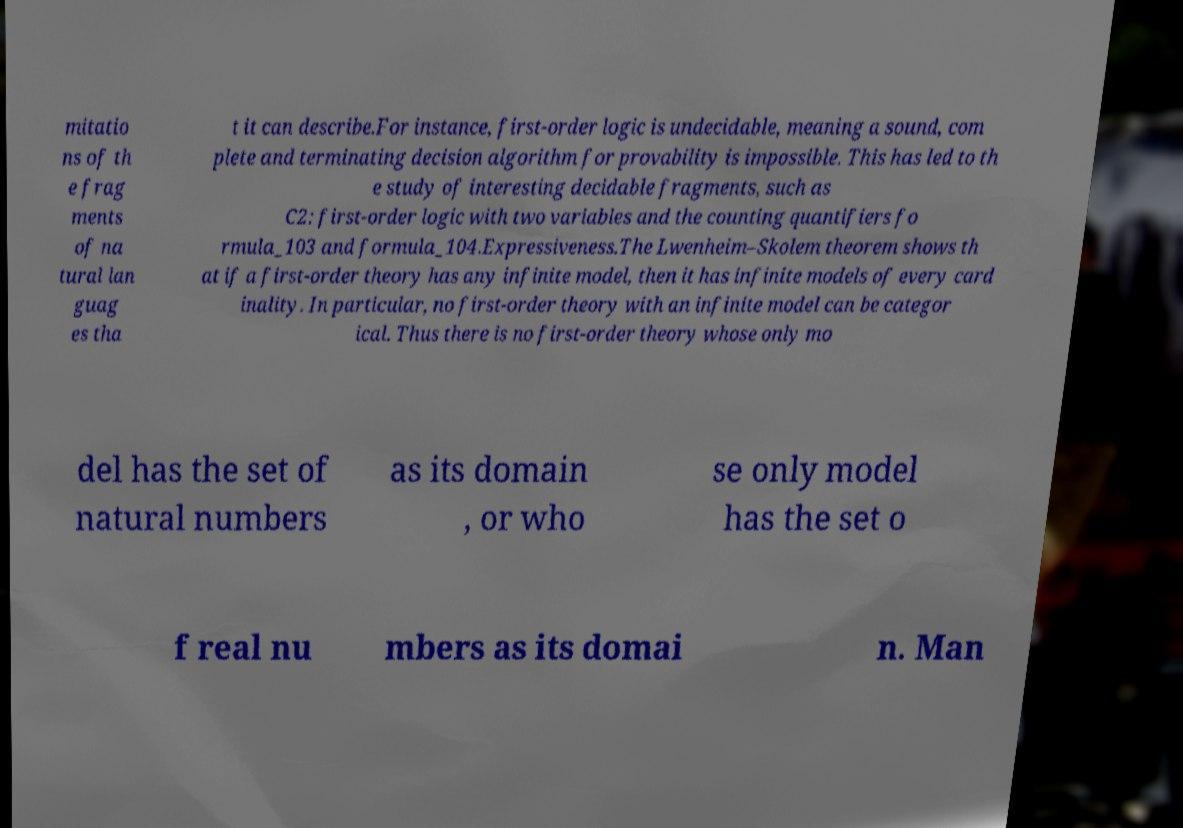What messages or text are displayed in this image? I need them in a readable, typed format. mitatio ns of th e frag ments of na tural lan guag es tha t it can describe.For instance, first-order logic is undecidable, meaning a sound, com plete and terminating decision algorithm for provability is impossible. This has led to th e study of interesting decidable fragments, such as C2: first-order logic with two variables and the counting quantifiers fo rmula_103 and formula_104.Expressiveness.The Lwenheim–Skolem theorem shows th at if a first-order theory has any infinite model, then it has infinite models of every card inality. In particular, no first-order theory with an infinite model can be categor ical. Thus there is no first-order theory whose only mo del has the set of natural numbers as its domain , or who se only model has the set o f real nu mbers as its domai n. Man 